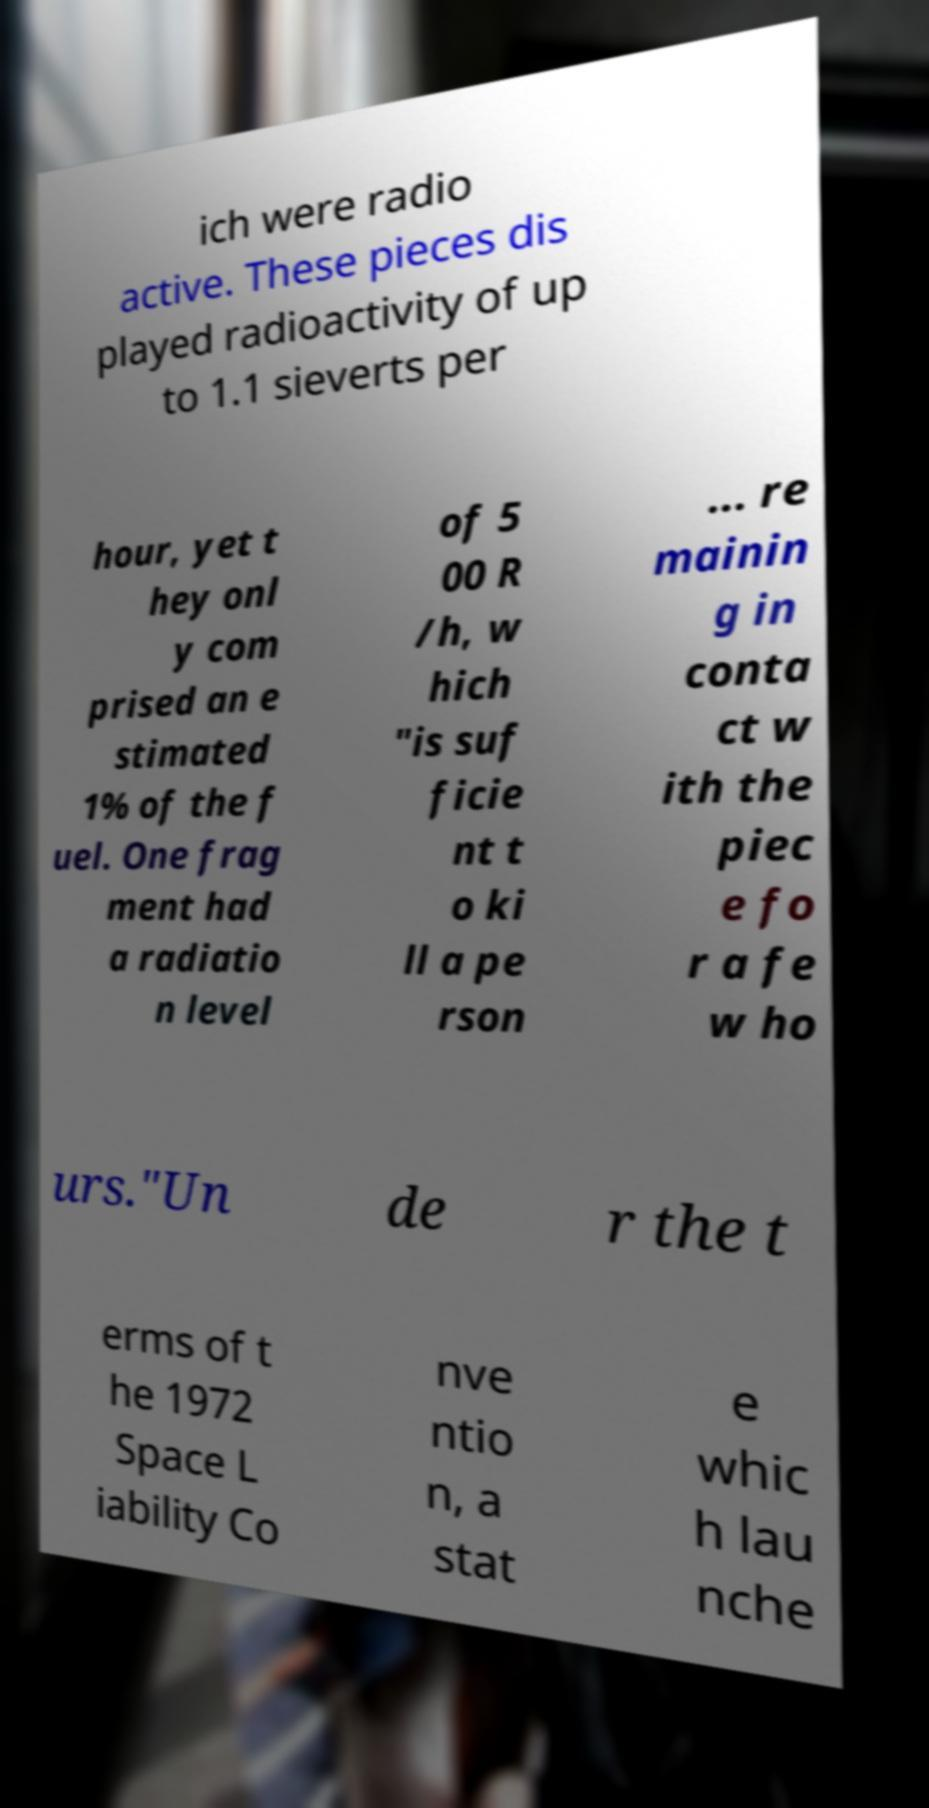Can you read and provide the text displayed in the image?This photo seems to have some interesting text. Can you extract and type it out for me? ich were radio active. These pieces dis played radioactivity of up to 1.1 sieverts per hour, yet t hey onl y com prised an e stimated 1% of the f uel. One frag ment had a radiatio n level of 5 00 R /h, w hich "is suf ficie nt t o ki ll a pe rson ... re mainin g in conta ct w ith the piec e fo r a fe w ho urs."Un de r the t erms of t he 1972 Space L iability Co nve ntio n, a stat e whic h lau nche 